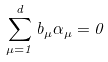Convert formula to latex. <formula><loc_0><loc_0><loc_500><loc_500>\sum _ { \mu = 1 } ^ { d } b _ { \mu } \alpha _ { \mu } = 0</formula> 